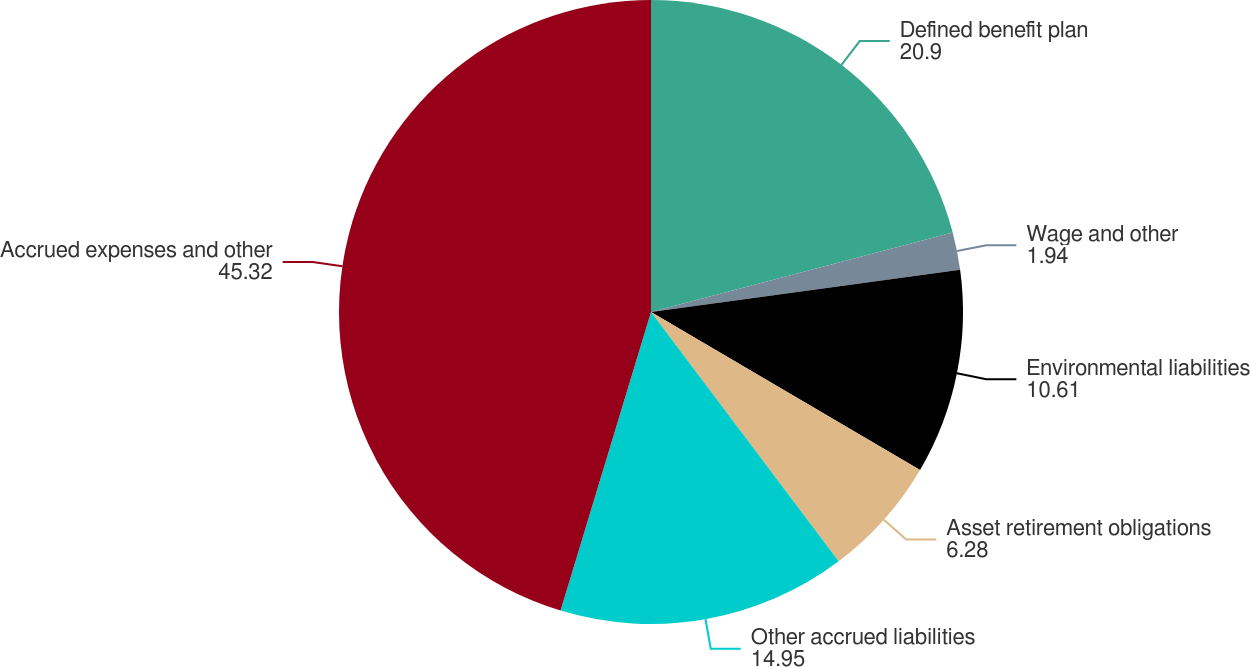Convert chart. <chart><loc_0><loc_0><loc_500><loc_500><pie_chart><fcel>Defined benefit plan<fcel>Wage and other<fcel>Environmental liabilities<fcel>Asset retirement obligations<fcel>Other accrued liabilities<fcel>Accrued expenses and other<nl><fcel>20.9%<fcel>1.94%<fcel>10.61%<fcel>6.28%<fcel>14.95%<fcel>45.32%<nl></chart> 